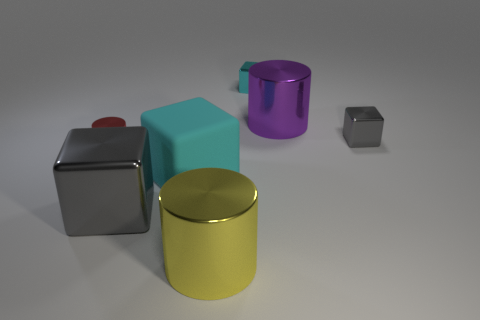There is a gray metal thing that is behind the large gray cube; how big is it?
Make the answer very short. Small. There is a metallic cylinder in front of the large matte cube; is its size the same as the block that is in front of the rubber block?
Ensure brevity in your answer.  Yes. How many other cubes have the same material as the big gray block?
Your answer should be very brief. 2. The rubber thing has what color?
Offer a very short reply. Cyan. Are there any cyan matte objects behind the large purple cylinder?
Keep it short and to the point. No. Is the tiny cylinder the same color as the big metal cube?
Offer a terse response. No. How many other shiny cylinders have the same color as the small shiny cylinder?
Offer a very short reply. 0. How big is the gray metallic block on the right side of the large cylinder behind the tiny gray block?
Your answer should be very brief. Small. What shape is the cyan matte object?
Keep it short and to the point. Cube. What is the material of the gray block in front of the tiny cylinder?
Provide a short and direct response. Metal. 